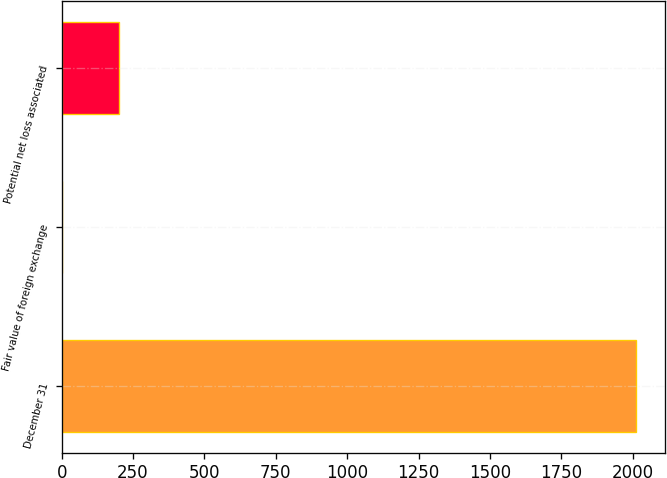<chart> <loc_0><loc_0><loc_500><loc_500><bar_chart><fcel>December 31<fcel>Fair value of foreign exchange<fcel>Potential net loss associated<nl><fcel>2012<fcel>1.2<fcel>202.28<nl></chart> 